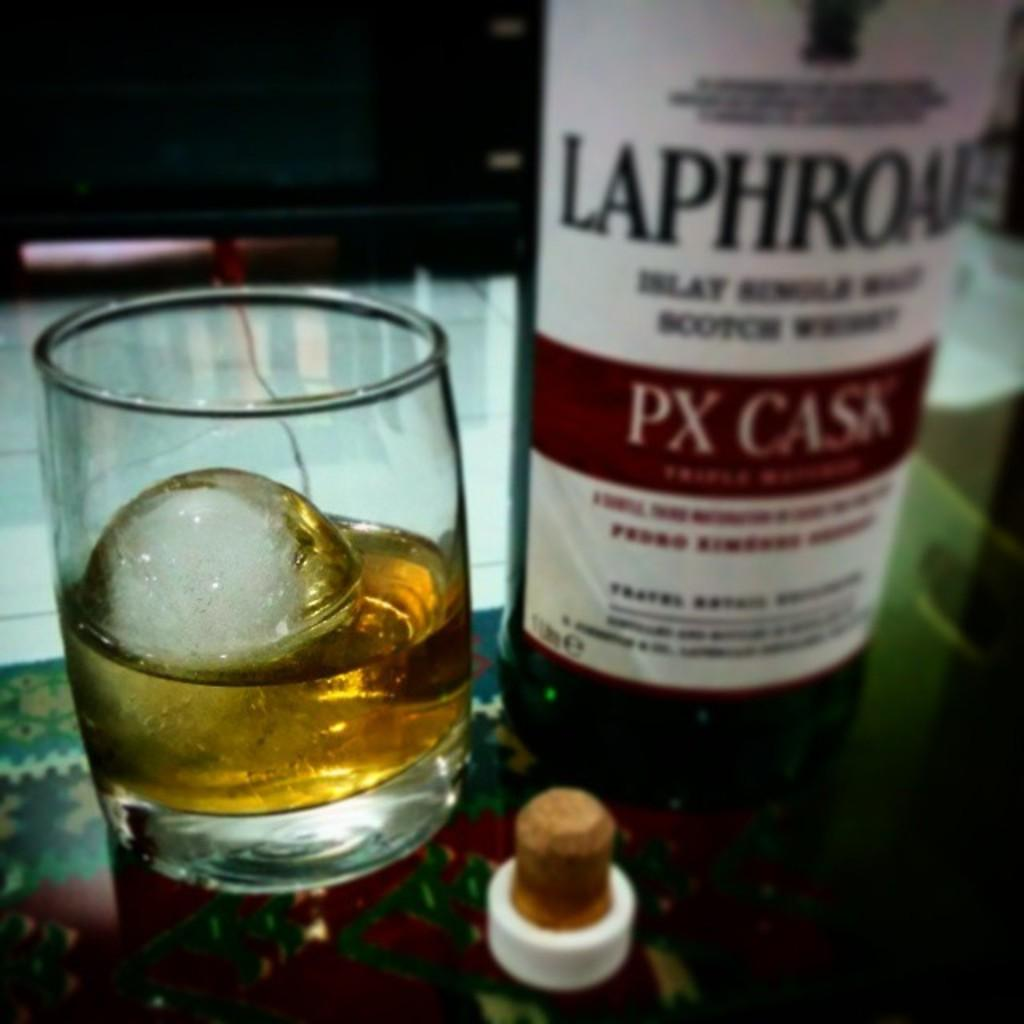Provide a one-sentence caption for the provided image. A bottle of PX cask next to a glass with an ice cube in it. 